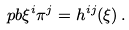<formula> <loc_0><loc_0><loc_500><loc_500>\ p b { \xi ^ { i } } { \pi ^ { j } } = h ^ { i j } ( \xi ) \, .</formula> 